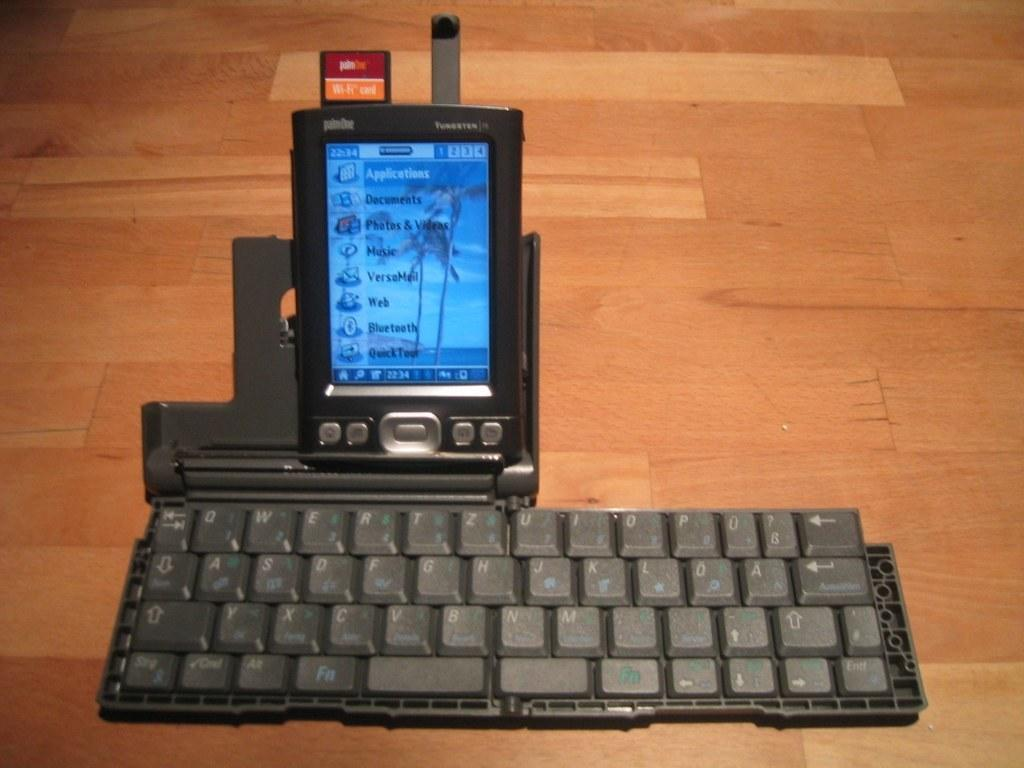<image>
Share a concise interpretation of the image provided. A phone on a keyboard has an wifi card on the top of it. 